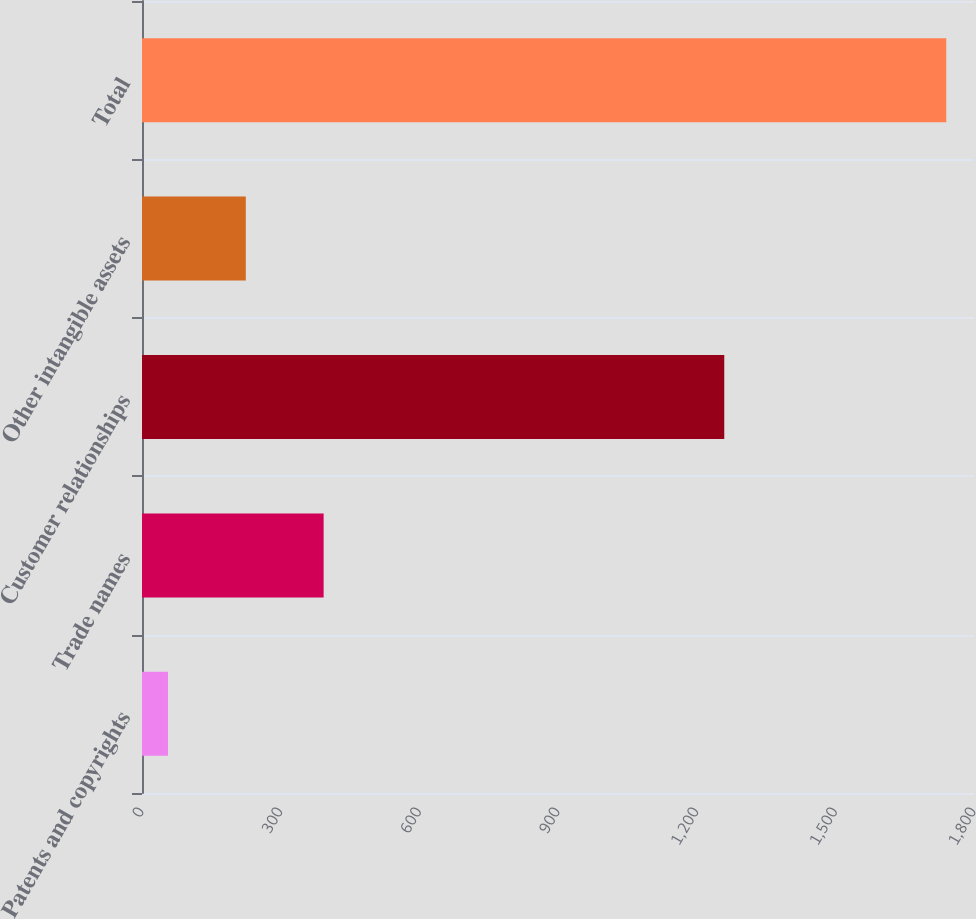<chart> <loc_0><loc_0><loc_500><loc_500><bar_chart><fcel>Patents and copyrights<fcel>Trade names<fcel>Customer relationships<fcel>Other intangible assets<fcel>Total<nl><fcel>56.2<fcel>392.96<fcel>1259.7<fcel>224.58<fcel>1740<nl></chart> 